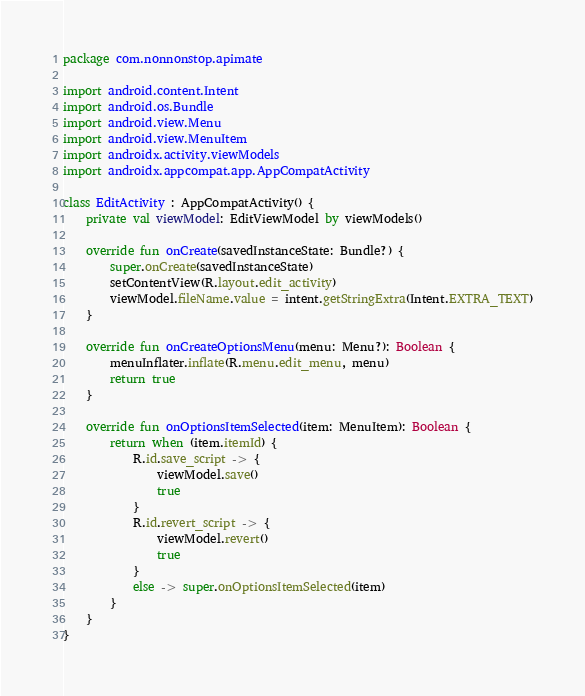<code> <loc_0><loc_0><loc_500><loc_500><_Kotlin_>package com.nonnonstop.apimate

import android.content.Intent
import android.os.Bundle
import android.view.Menu
import android.view.MenuItem
import androidx.activity.viewModels
import androidx.appcompat.app.AppCompatActivity

class EditActivity : AppCompatActivity() {
    private val viewModel: EditViewModel by viewModels()

    override fun onCreate(savedInstanceState: Bundle?) {
        super.onCreate(savedInstanceState)
        setContentView(R.layout.edit_activity)
        viewModel.fileName.value = intent.getStringExtra(Intent.EXTRA_TEXT)
    }

    override fun onCreateOptionsMenu(menu: Menu?): Boolean {
        menuInflater.inflate(R.menu.edit_menu, menu)
        return true
    }

    override fun onOptionsItemSelected(item: MenuItem): Boolean {
        return when (item.itemId) {
            R.id.save_script -> {
                viewModel.save()
                true
            }
            R.id.revert_script -> {
                viewModel.revert()
                true
            }
            else -> super.onOptionsItemSelected(item)
        }
    }
}</code> 